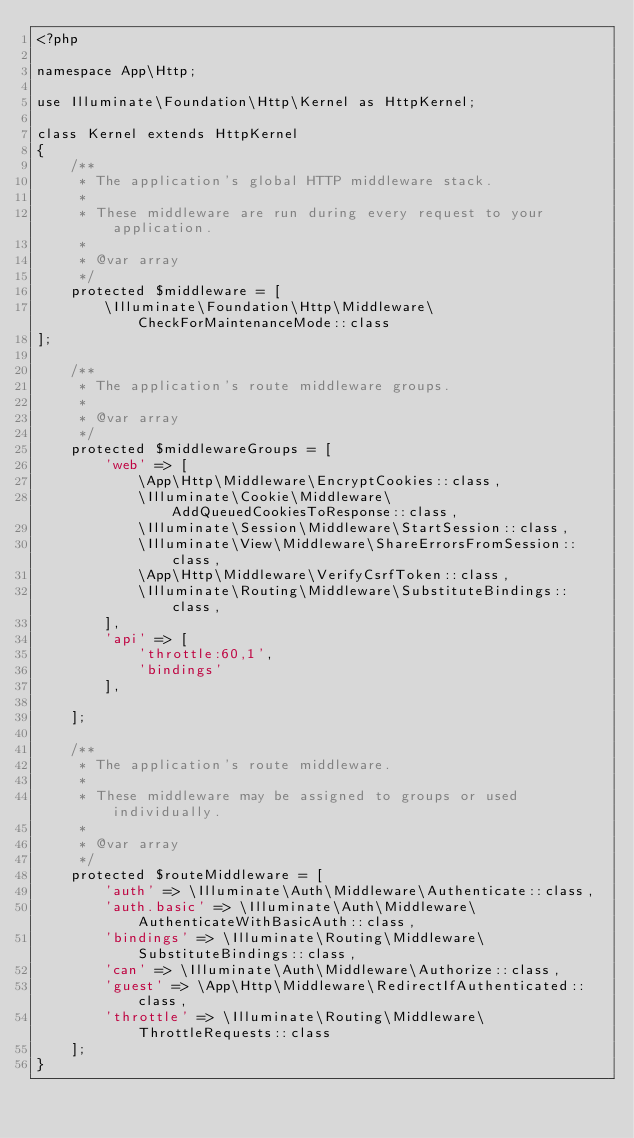Convert code to text. <code><loc_0><loc_0><loc_500><loc_500><_PHP_><?php

namespace App\Http;

use Illuminate\Foundation\Http\Kernel as HttpKernel;

class Kernel extends HttpKernel
{
    /**
     * The application's global HTTP middleware stack.
     *
     * These middleware are run during every request to your application.
     *
     * @var array
     */
    protected $middleware = [
        \Illuminate\Foundation\Http\Middleware\CheckForMaintenanceMode::class
];

    /**
     * The application's route middleware groups.
     *
     * @var array
     */
    protected $middlewareGroups = [
        'web' => [
            \App\Http\Middleware\EncryptCookies::class,
            \Illuminate\Cookie\Middleware\AddQueuedCookiesToResponse::class,
            \Illuminate\Session\Middleware\StartSession::class,
            \Illuminate\View\Middleware\ShareErrorsFromSession::class,
            \App\Http\Middleware\VerifyCsrfToken::class,
            \Illuminate\Routing\Middleware\SubstituteBindings::class,
        ],
        'api' => [
            'throttle:60,1',
            'bindings'
        ],

    ];

    /**
     * The application's route middleware.
     *
     * These middleware may be assigned to groups or used individually.
     *
     * @var array
     */
    protected $routeMiddleware = [
        'auth' => \Illuminate\Auth\Middleware\Authenticate::class,
        'auth.basic' => \Illuminate\Auth\Middleware\AuthenticateWithBasicAuth::class,
        'bindings' => \Illuminate\Routing\Middleware\SubstituteBindings::class,
        'can' => \Illuminate\Auth\Middleware\Authorize::class,
        'guest' => \App\Http\Middleware\RedirectIfAuthenticated::class,
        'throttle' => \Illuminate\Routing\Middleware\ThrottleRequests::class
    ];
}
</code> 